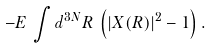Convert formula to latex. <formula><loc_0><loc_0><loc_500><loc_500>- E \, \int d ^ { 3 N } R \, \left ( | X ( R ) | ^ { 2 } - 1 \right ) .</formula> 